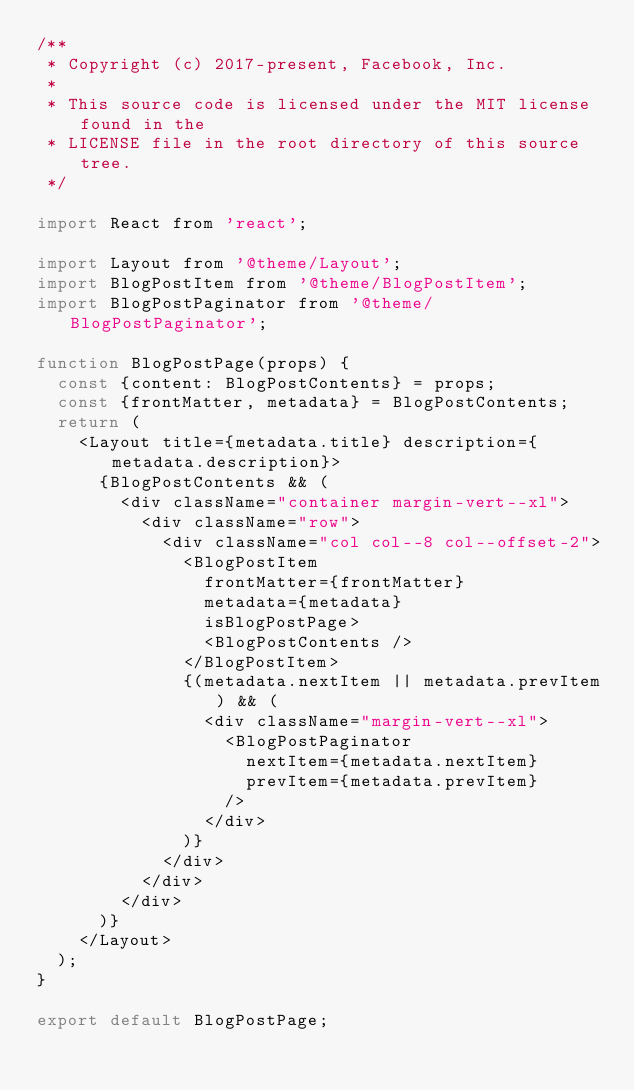<code> <loc_0><loc_0><loc_500><loc_500><_JavaScript_>/**
 * Copyright (c) 2017-present, Facebook, Inc.
 *
 * This source code is licensed under the MIT license found in the
 * LICENSE file in the root directory of this source tree.
 */

import React from 'react';

import Layout from '@theme/Layout';
import BlogPostItem from '@theme/BlogPostItem';
import BlogPostPaginator from '@theme/BlogPostPaginator';

function BlogPostPage(props) {
  const {content: BlogPostContents} = props;
  const {frontMatter, metadata} = BlogPostContents;
  return (
    <Layout title={metadata.title} description={metadata.description}>
      {BlogPostContents && (
        <div className="container margin-vert--xl">
          <div className="row">
            <div className="col col--8 col--offset-2">
              <BlogPostItem
                frontMatter={frontMatter}
                metadata={metadata}
                isBlogPostPage>
                <BlogPostContents />
              </BlogPostItem>
              {(metadata.nextItem || metadata.prevItem) && (
                <div className="margin-vert--xl">
                  <BlogPostPaginator
                    nextItem={metadata.nextItem}
                    prevItem={metadata.prevItem}
                  />
                </div>
              )}
            </div>
          </div>
        </div>
      )}
    </Layout>
  );
}

export default BlogPostPage;
</code> 